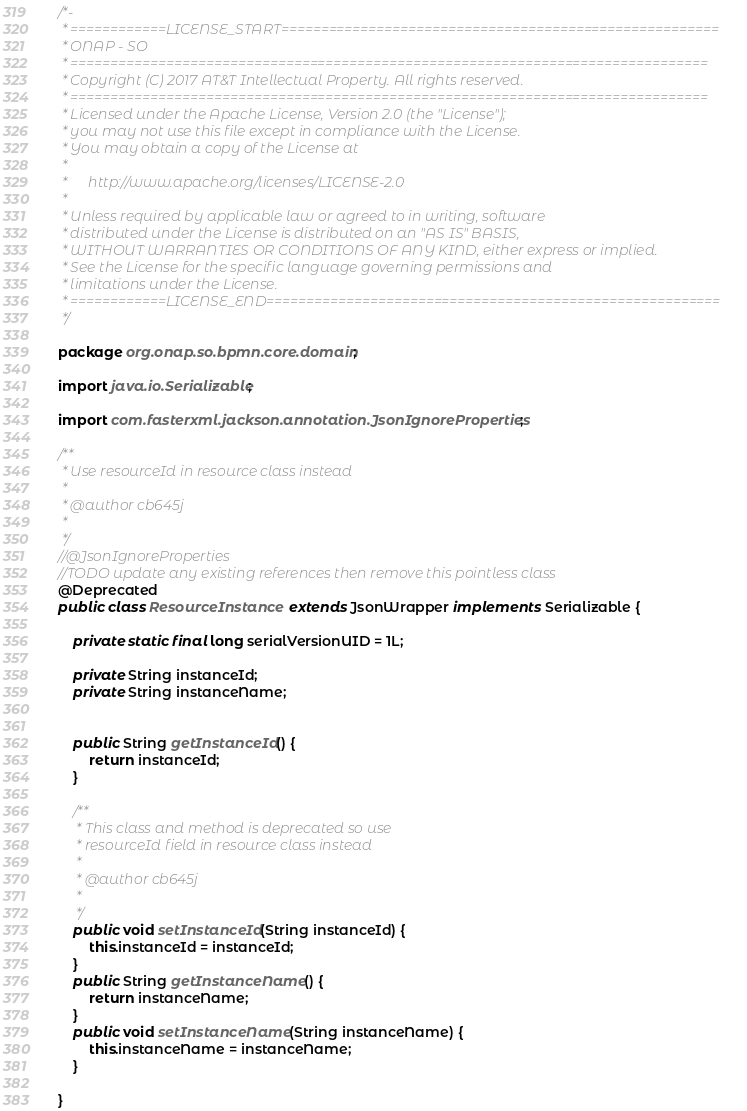<code> <loc_0><loc_0><loc_500><loc_500><_Java_>/*-
 * ============LICENSE_START=======================================================
 * ONAP - SO
 * ================================================================================
 * Copyright (C) 2017 AT&T Intellectual Property. All rights reserved.
 * ================================================================================
 * Licensed under the Apache License, Version 2.0 (the "License");
 * you may not use this file except in compliance with the License.
 * You may obtain a copy of the License at
 * 
 *      http://www.apache.org/licenses/LICENSE-2.0
 * 
 * Unless required by applicable law or agreed to in writing, software
 * distributed under the License is distributed on an "AS IS" BASIS,
 * WITHOUT WARRANTIES OR CONDITIONS OF ANY KIND, either express or implied.
 * See the License for the specific language governing permissions and
 * limitations under the License.
 * ============LICENSE_END=========================================================
 */

package org.onap.so.bpmn.core.domain;

import java.io.Serializable;

import com.fasterxml.jackson.annotation.JsonIgnoreProperties;

/**
 * Use resourceId in resource class instead
 *
 * @author cb645j
 *
 */
//@JsonIgnoreProperties
//TODO update any existing references then remove this pointless class
@Deprecated
public class ResourceInstance  extends JsonWrapper implements Serializable {

	private static final long serialVersionUID = 1L;

	private String instanceId;
	private String instanceName;


	public String getInstanceId() {
		return instanceId;
	}

	/**
	 * This class and method is deprecated so use
	 * resourceId field in resource class instead
	 *
	 * @author cb645j
	 *
	 */
	public void setInstanceId(String instanceId) {
		this.instanceId = instanceId;
	}
	public String getInstanceName() {
		return instanceName;
	}
	public void setInstanceName(String instanceName) {
		this.instanceName = instanceName;
	}

}</code> 